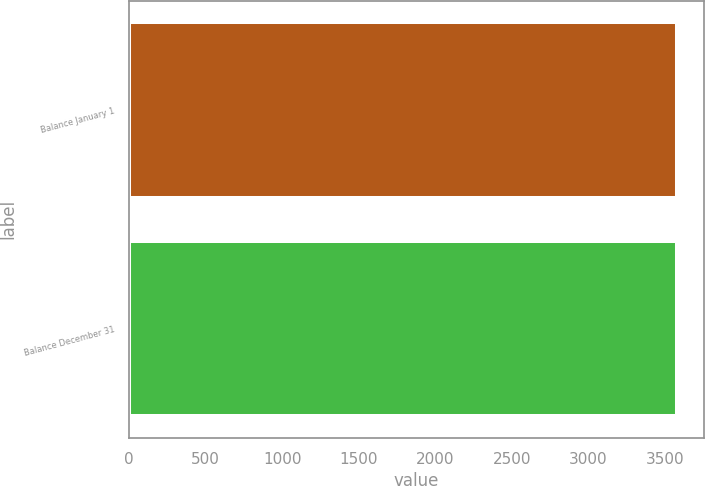Convert chart to OTSL. <chart><loc_0><loc_0><loc_500><loc_500><bar_chart><fcel>Balance January 1<fcel>Balance December 31<nl><fcel>3577<fcel>3577.1<nl></chart> 